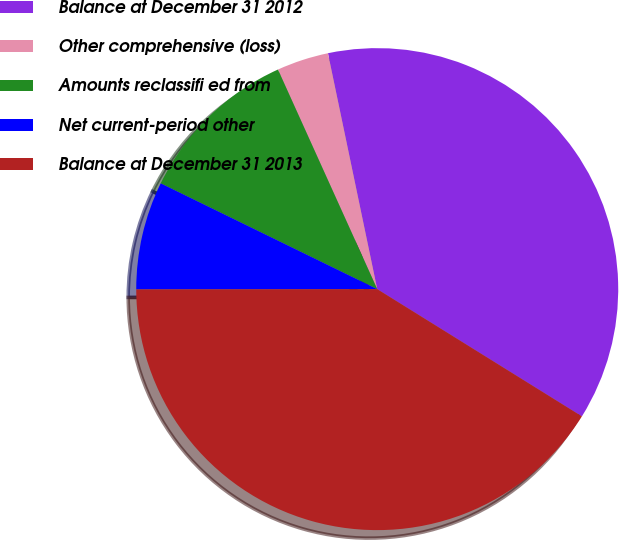Convert chart to OTSL. <chart><loc_0><loc_0><loc_500><loc_500><pie_chart><fcel>Balance at December 31 2012<fcel>Other comprehensive (loss)<fcel>Amounts reclassifi ed from<fcel>Net current-period other<fcel>Balance at December 31 2013<nl><fcel>37.13%<fcel>3.48%<fcel>11.01%<fcel>7.25%<fcel>41.13%<nl></chart> 